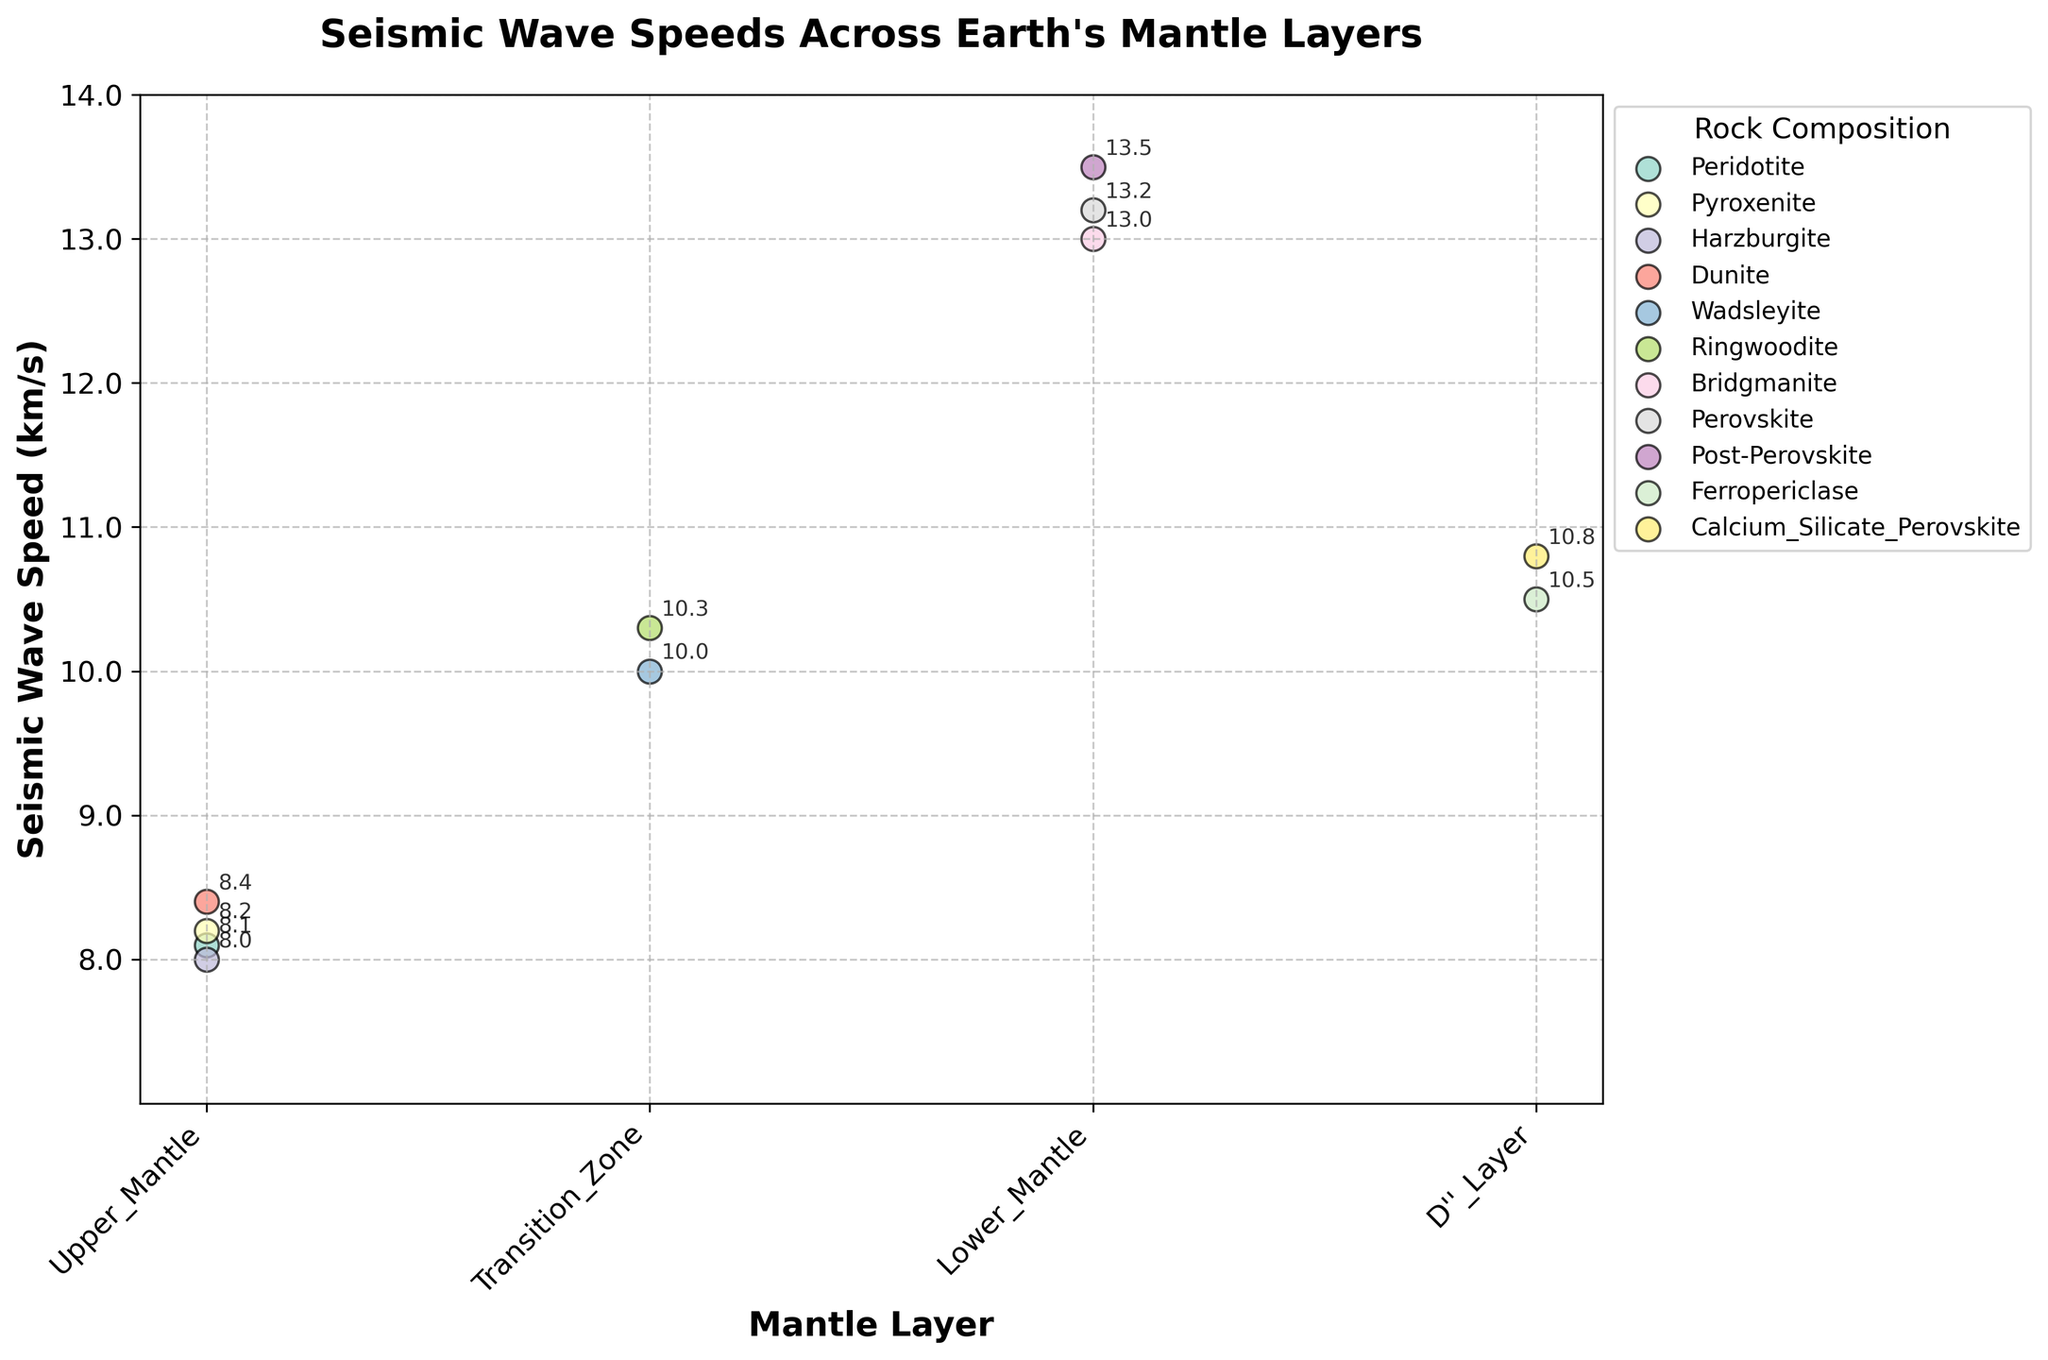What is the title of the plot? The title of the plot is usually found at the top center, and it provides a summary of what the figure is about. In this case, the title is given as "Seismic Wave Speeds Across Earth's Mantle Layers".
Answer: Seismic Wave Speeds Across Earth's Mantle Layers Which rock composition in the Upper Mantle has the highest seismic wave speed? First, locate the "Upper Mantle" layer on the x-axis. Then, read the seismic wave speeds for each rock composition within this layer. The highest value is the one related to Dunite, which is 8.4 km/s.
Answer: Dunite What is the range of seismic wave speeds observed in the Transition Zone? Identify the seismic wave speed values for the Transition Zone: Wadsleyite (10.0 km/s) and Ringwoodite (10.3 km/s). The range is the difference between the highest and lowest speeds, which is 10.3 - 10.0 = 0.3 km/s.
Answer: 0.3 km/s Compare seismic wave speeds between Bridgmanite in the Lower Mantle and Ferropericlase in the D'' Layer. Which is higher? Find the seismic wave speed for Bridgmanite in the Lower Mantle (13.0 km/s) and compare it with the speed for Ferropericlase in the D'' Layer (10.5 km/s). Bridgmanite has a higher speed.
Answer: Bridgmanite Which layer of Earth's mantle has the maximum variety in rock compositions shown in the plot? Count the number of different rock compositions for each mantle layer: the Upper Mantle has 4, the Transition Zone has 2, the Lower Mantle has 3, and the D'' Layer has 2. The layer with the maximum variety in rock compositions is the Upper Mantle.
Answer: Upper Mantle What is the average seismic wave speed for rocks in the Lower Mantle? The seismic wave speeds for the Lower Mantle are Bridgmanite (13.0 km/s), Perovskite (13.2 km/s), and Post-Perovskite (13.5 km/s). The average is calculated as (13.0 + 13.2 + 13.5) / 3 = 13.23 km/s.
Answer: 13.23 km/s How does the seismic wave speed of Wadsleyite compare to that of Calcium Silicate Perovskite? Wadsleyite, found in the Transition Zone, has a seismic wave speed of 10.0 km/s. Calcium Silicate Perovskite in the D'' Layer has a speed of 10.8 km/s. Calcium Silicate Perovskite has a higher speed.
Answer: Calcium Silicate Perovskite Which rock composition in the plot represents the highest seismic wave speed, and what is its value? Scan the entire plot to find the maximum seismic wave speed value. The highest value observed is 13.5 km/s, which corresponds to Post-Perovskite in the Lower Mantle.
Answer: Post-Perovskite, 13.5 km/s What's the difference in seismic wave speed between the fastest and slowest rock compositions in the Upper Mantle? The rock compositions in the Upper Mantle are Peridotite (8.1 km/s), Pyroxenite (8.2 km/s), Harzburgite (8.0 km/s), and Dunite (8.4 km/s). The fastest is Dunite (8.4 km/s) and the slowest is Harzburgite (8.0 km/s), giving a difference of 8.4 - 8.0 = 0.4 km/s.
Answer: 0.4 km/s 